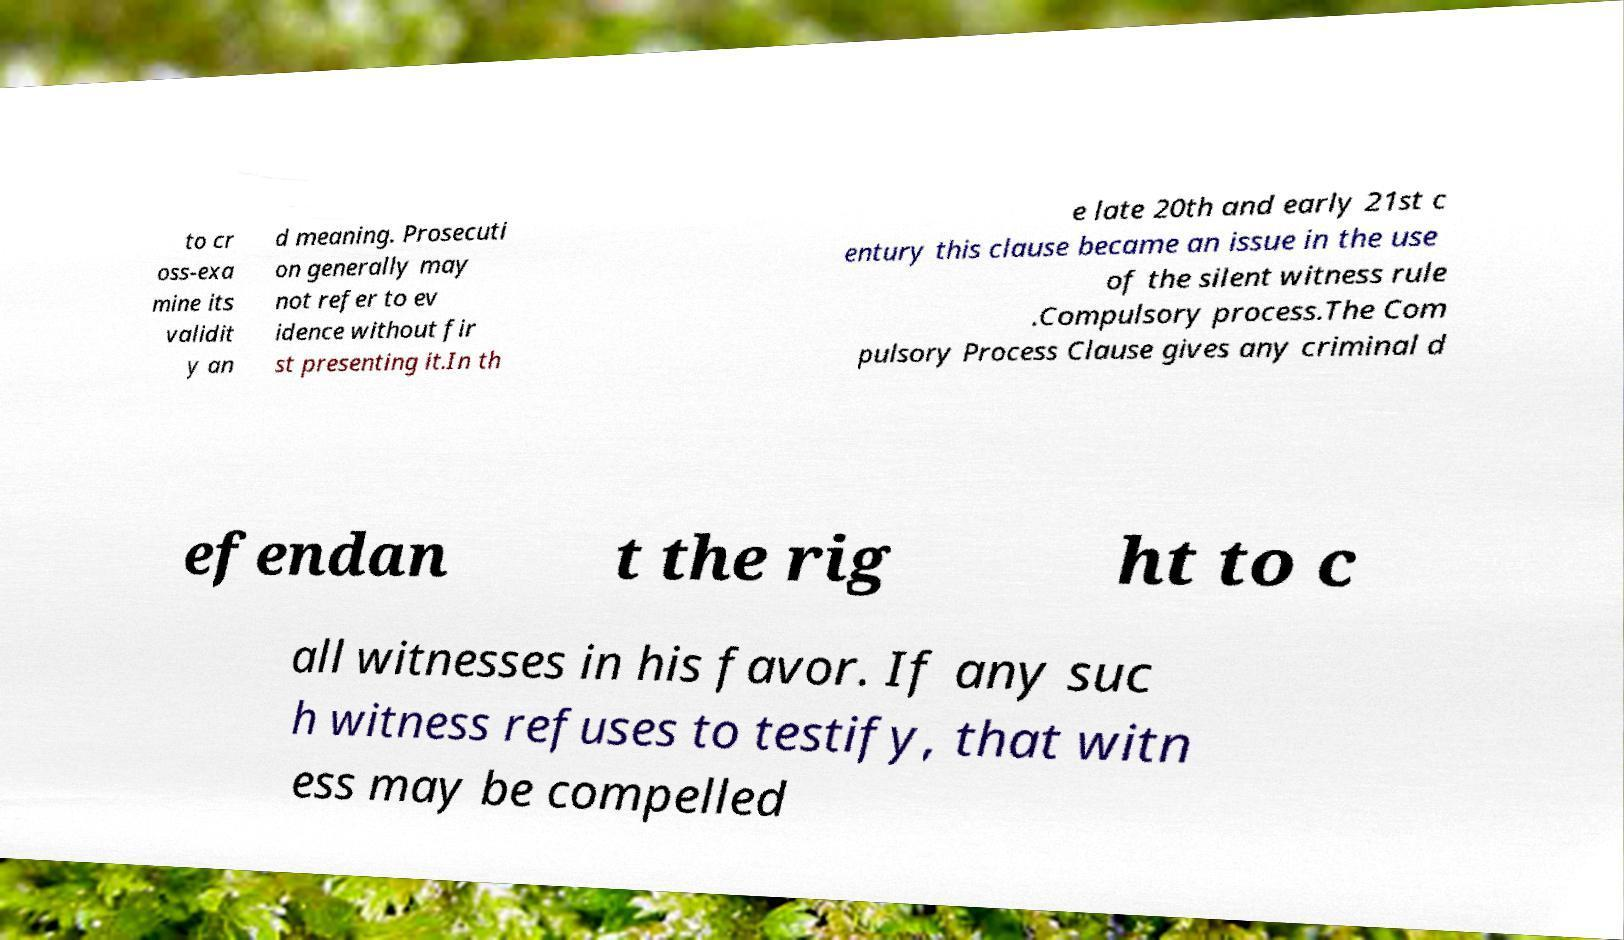There's text embedded in this image that I need extracted. Can you transcribe it verbatim? to cr oss-exa mine its validit y an d meaning. Prosecuti on generally may not refer to ev idence without fir st presenting it.In th e late 20th and early 21st c entury this clause became an issue in the use of the silent witness rule .Compulsory process.The Com pulsory Process Clause gives any criminal d efendan t the rig ht to c all witnesses in his favor. If any suc h witness refuses to testify, that witn ess may be compelled 